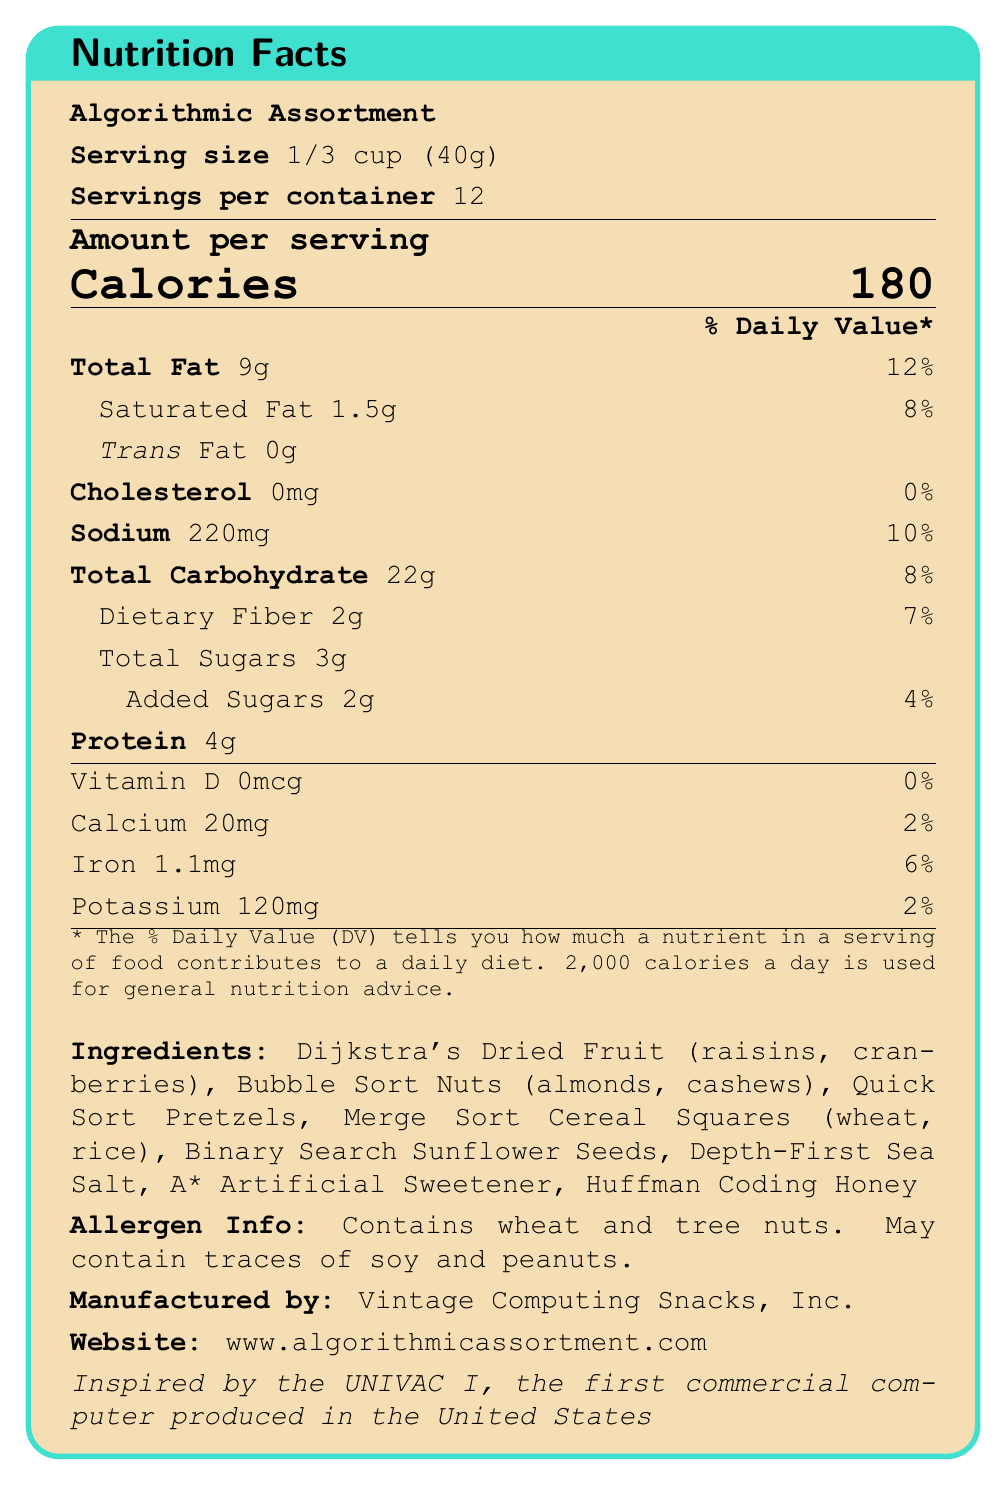what is the serving size? The serving size is explicitly mentioned in the document as "1/3 cup (40g)".
Answer: 1/3 cup (40g) how many servings are there per container? The document lists "Servings per container" as 12.
Answer: 12 what is the amount of total fat per serving? The document states that the "Total Fat" per serving is 9g.
Answer: 9g what allergens are present in the snack mix? The document provides an "Allergen Info" section that states the presence of wheat and tree nuts.
Answer: Wheat and tree nuts who is the manufacturer of the product? The manufacturer is specified at the end of the document as "Vintage Computing Snacks, Inc."
Answer: Vintage Computing Snacks, Inc. how many calories are there per serving? The document mentions "Calories" per serving as 180 in the "Amount per serving" section.
Answer: 180 what is the flowchart-style design showcasing on the packaging? The document lists "Flowchart-style design showcasing famous algorithms" as one of the packaging features.
Answer: Famous algorithms what is the daily value percentage of dietary fiber per serving? The document states that the "Dietary Fiber" daily value per serving is 7%.
Answer: 7% what is the calcium content per serving? The document lists "Calcium" as 20mg per serving.
Answer: 20mg what is the URL of the product website? The document specifies the website URL as "www.algorithmicassortment.com".
Answer: www.algorithmicassortment.com which fact is included about Alan Turing on the packaging? The document mentions a fun fact about Alan Turing on the side panel, but it does not specify what the fact is.
Answer: Cannot be determined what is the main idea of the document? The document includes detailed nutritional facts, ingredients, allergen information, packaging features, manufacturer details, a historical note, and a website address related to the product "Algorithmic Assortment."
Answer: The document provides nutritional facts, ingredient information, allergen info, and packaging features for a snack mix called "Algorithmic Assortment," inspired by famous computing algorithms and historical computing figures. what is the amount of added sugars per serving? A. 1g B. 2g C. 3g The document lists "Added Sugars" amount as 2g per serving.
Answer: B what is the historical note mentioned in the document? A. Inspired by the ENIAC, one of the first computers B. Inspired by the UNIVAC I, the first commercial computer produced in the United States C. Inspired by the Colossus, the first programmable digital computer The document states that the product is "Inspired by the UNIVAC I, the first commercial computer produced in the United States."
Answer: B does the product contain trans fat? The document lists "Trans Fat" as 0g, indicating that the product does not contain trans fat.
Answer: No how much sodium is there per serving? The document lists "Sodium" as 220mg per serving.
Answer: 220mg 